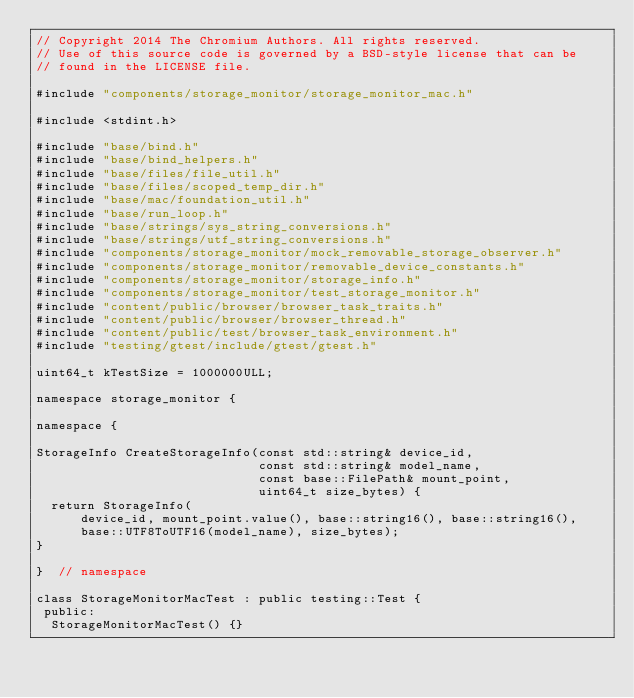<code> <loc_0><loc_0><loc_500><loc_500><_ObjectiveC_>// Copyright 2014 The Chromium Authors. All rights reserved.
// Use of this source code is governed by a BSD-style license that can be
// found in the LICENSE file.

#include "components/storage_monitor/storage_monitor_mac.h"

#include <stdint.h>

#include "base/bind.h"
#include "base/bind_helpers.h"
#include "base/files/file_util.h"
#include "base/files/scoped_temp_dir.h"
#include "base/mac/foundation_util.h"
#include "base/run_loop.h"
#include "base/strings/sys_string_conversions.h"
#include "base/strings/utf_string_conversions.h"
#include "components/storage_monitor/mock_removable_storage_observer.h"
#include "components/storage_monitor/removable_device_constants.h"
#include "components/storage_monitor/storage_info.h"
#include "components/storage_monitor/test_storage_monitor.h"
#include "content/public/browser/browser_task_traits.h"
#include "content/public/browser/browser_thread.h"
#include "content/public/test/browser_task_environment.h"
#include "testing/gtest/include/gtest/gtest.h"

uint64_t kTestSize = 1000000ULL;

namespace storage_monitor {

namespace {

StorageInfo CreateStorageInfo(const std::string& device_id,
                              const std::string& model_name,
                              const base::FilePath& mount_point,
                              uint64_t size_bytes) {
  return StorageInfo(
      device_id, mount_point.value(), base::string16(), base::string16(),
      base::UTF8ToUTF16(model_name), size_bytes);
}

}  // namespace

class StorageMonitorMacTest : public testing::Test {
 public:
  StorageMonitorMacTest() {}
</code> 